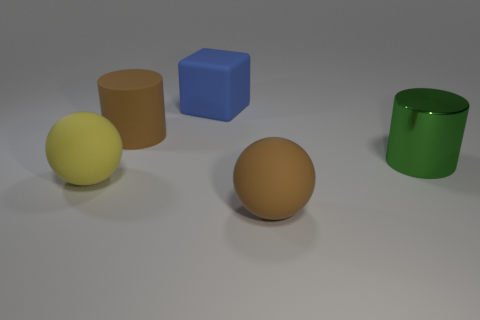Subtract all red cylinders. Subtract all purple cubes. How many cylinders are left? 2 Add 2 red matte balls. How many objects exist? 7 Subtract all cylinders. How many objects are left? 3 Subtract all large green shiny objects. Subtract all yellow rubber balls. How many objects are left? 3 Add 2 big things. How many big things are left? 7 Add 5 small blue spheres. How many small blue spheres exist? 5 Subtract 0 purple spheres. How many objects are left? 5 